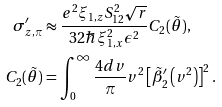Convert formula to latex. <formula><loc_0><loc_0><loc_500><loc_500>\sigma _ { z , \pi } ^ { \prime } & \approx \frac { e ^ { 2 } \xi _ { 1 , z } S _ { 1 2 } ^ { 2 } \sqrt { r } } { 3 2 \hbar { \xi } _ { 1 , x } ^ { 2 } \epsilon ^ { 2 } } C _ { 2 } ( \tilde { \theta } ) , \\ C _ { 2 } ( \tilde { \theta } ) & = \int _ { 0 } ^ { \infty } \frac { 4 d v } { \pi } v ^ { 2 } \left [ \tilde { \beta } ^ { \prime } _ { 2 } \left ( v ^ { 2 } \right ) \right ] ^ { 2 } .</formula> 